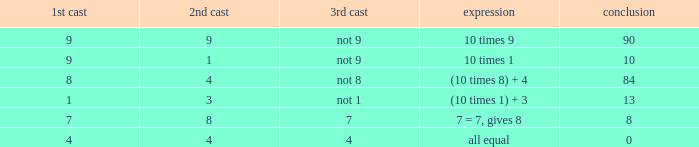If the equation is (10 times 8) + 4, what would be the 2nd throw? 4.0. 